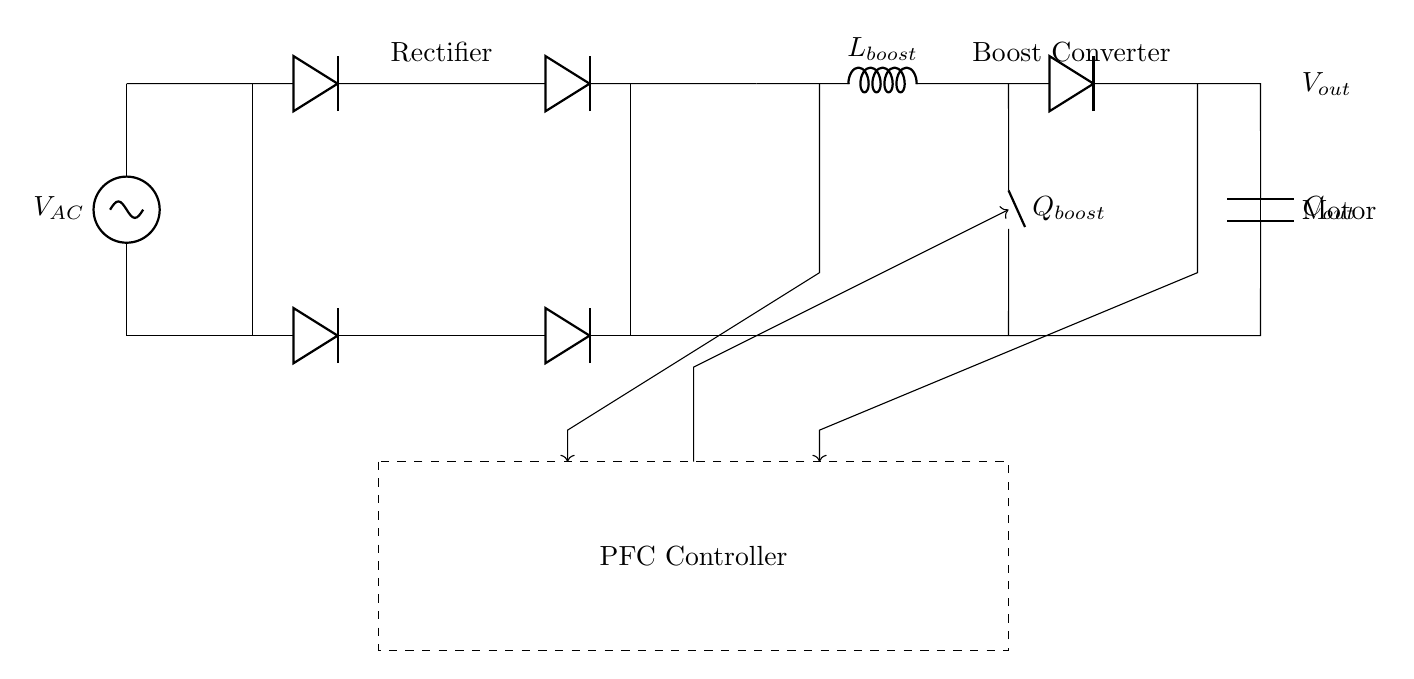What components are in this circuit? The main components in the circuit are the AC source, rectifier, boost converter, output capacitor, motor load, and PFC controller. Each of these contributes to the overall power factor correction and energy efficiency.
Answer: AC source, rectifier, boost converter, output capacitor, motor load, PFC controller What type of load is connected at the output? The load connected at the output is a motor, which is indicated by the labeling near the bottom right corner of the diagram. It represents an inductive load, commonly used in industrial applications.
Answer: Motor What is the role of the boost converter in this circuit? The boost converter raises the voltage level supplied to the motor. It takes the lower voltage from the rectifier and boosts it to a higher level, improving the efficiency of the power delivered to the motor.
Answer: Increases voltage What does the dashed rectangle represent? The dashed rectangle in the diagram represents the PFC (Power Factor Correction) controller, which regulates the circuit and ensures that the current and voltage are in phase, thereby improving the power factor of the system.
Answer: PFC Controller How many diodes are used in the rectifier section? There are four diodes in the rectifier section, which are configured to allow current to flow in one direction effectively converting AC voltage to DC voltage for further processing.
Answer: Four diodes What is the purpose of the output capacitor? The output capacitor smooths out the voltage waveform delivered to the motor, reducing ripples and providing a more stable DC voltage, which is essential for the efficient operation of the motor.
Answer: Smoothing DC voltage What feedback mechanism is indicated in the circuit? The feedback mechanism is indicated by the arrows pointing from voltage and current sensing lines to the PFC controller, showing that the controller adjusts its operation based on real-time voltage and current measurements to optimize performance.
Answer: Feedback from sensing lines 